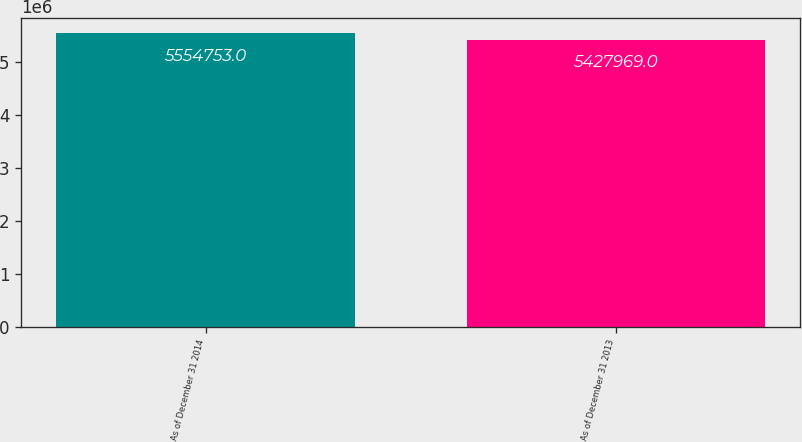Convert chart to OTSL. <chart><loc_0><loc_0><loc_500><loc_500><bar_chart><fcel>As of December 31 2014<fcel>As of December 31 2013<nl><fcel>5.55475e+06<fcel>5.42797e+06<nl></chart> 